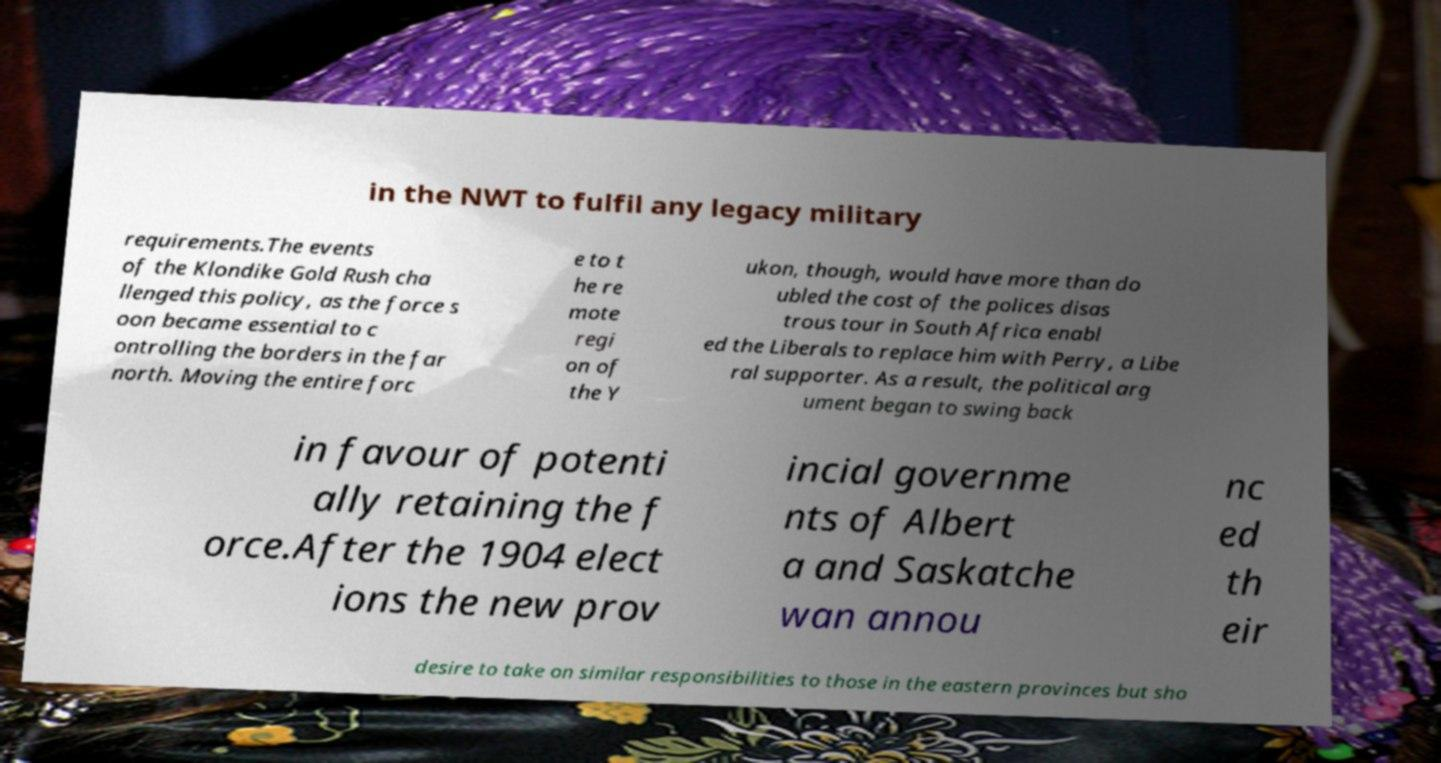Please identify and transcribe the text found in this image. in the NWT to fulfil any legacy military requirements.The events of the Klondike Gold Rush cha llenged this policy, as the force s oon became essential to c ontrolling the borders in the far north. Moving the entire forc e to t he re mote regi on of the Y ukon, though, would have more than do ubled the cost of the polices disas trous tour in South Africa enabl ed the Liberals to replace him with Perry, a Libe ral supporter. As a result, the political arg ument began to swing back in favour of potenti ally retaining the f orce.After the 1904 elect ions the new prov incial governme nts of Albert a and Saskatche wan annou nc ed th eir desire to take on similar responsibilities to those in the eastern provinces but sho 